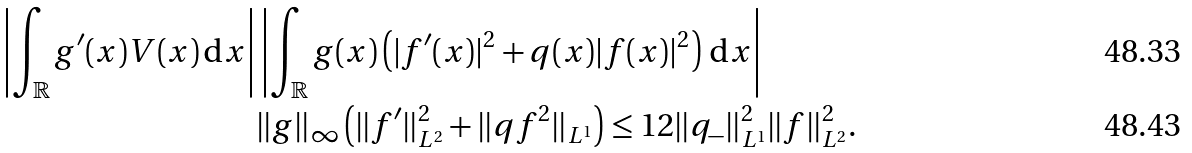Convert formula to latex. <formula><loc_0><loc_0><loc_500><loc_500>\left | \int _ { \mathbb { R } } g ^ { \prime } ( x ) V ( x ) \, \mathrm d x \right | & \left | \int _ { \mathbb { R } } g ( x ) \left ( | f ^ { \prime } ( x ) | ^ { 2 } + q ( x ) | f ( x ) | ^ { 2 } \right ) \, \mathrm d x \right | \\ & \| g \| _ { \infty } \left ( \| f ^ { \prime } \| _ { L ^ { 2 } } ^ { 2 } + \| q f ^ { 2 } \| _ { L ^ { 1 } } \right ) \leq 1 2 \| q _ { - } \| _ { L ^ { 1 } } ^ { 2 } \| f \| _ { L ^ { 2 } } ^ { 2 } .</formula> 